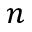Convert formula to latex. <formula><loc_0><loc_0><loc_500><loc_500>n</formula> 